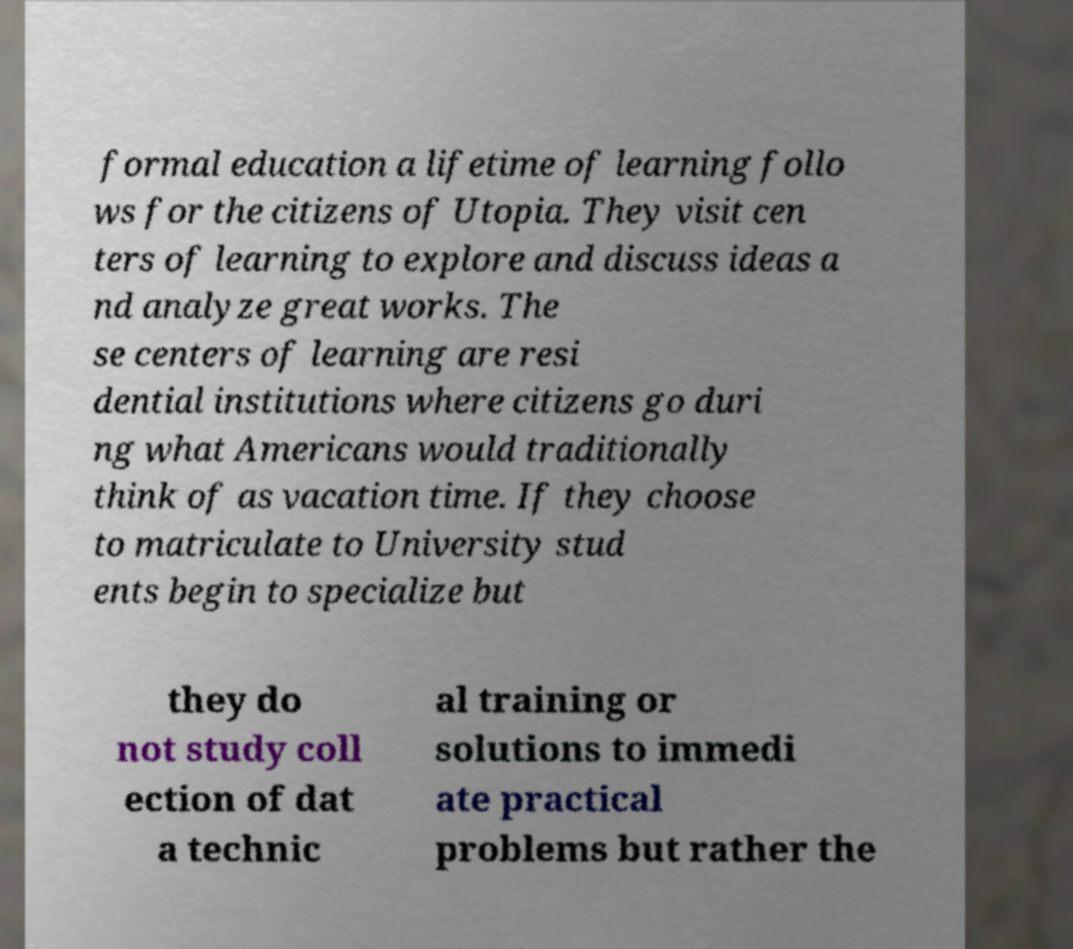Please read and relay the text visible in this image. What does it say? formal education a lifetime of learning follo ws for the citizens of Utopia. They visit cen ters of learning to explore and discuss ideas a nd analyze great works. The se centers of learning are resi dential institutions where citizens go duri ng what Americans would traditionally think of as vacation time. If they choose to matriculate to University stud ents begin to specialize but they do not study coll ection of dat a technic al training or solutions to immedi ate practical problems but rather the 